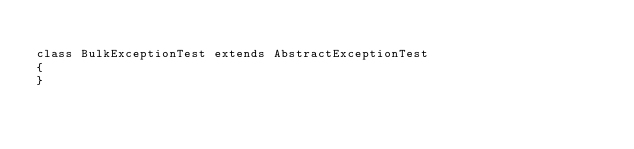Convert code to text. <code><loc_0><loc_0><loc_500><loc_500><_PHP_>
class BulkExceptionTest extends AbstractExceptionTest
{
}
</code> 